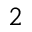Convert formula to latex. <formula><loc_0><loc_0><loc_500><loc_500>^ { 2 }</formula> 